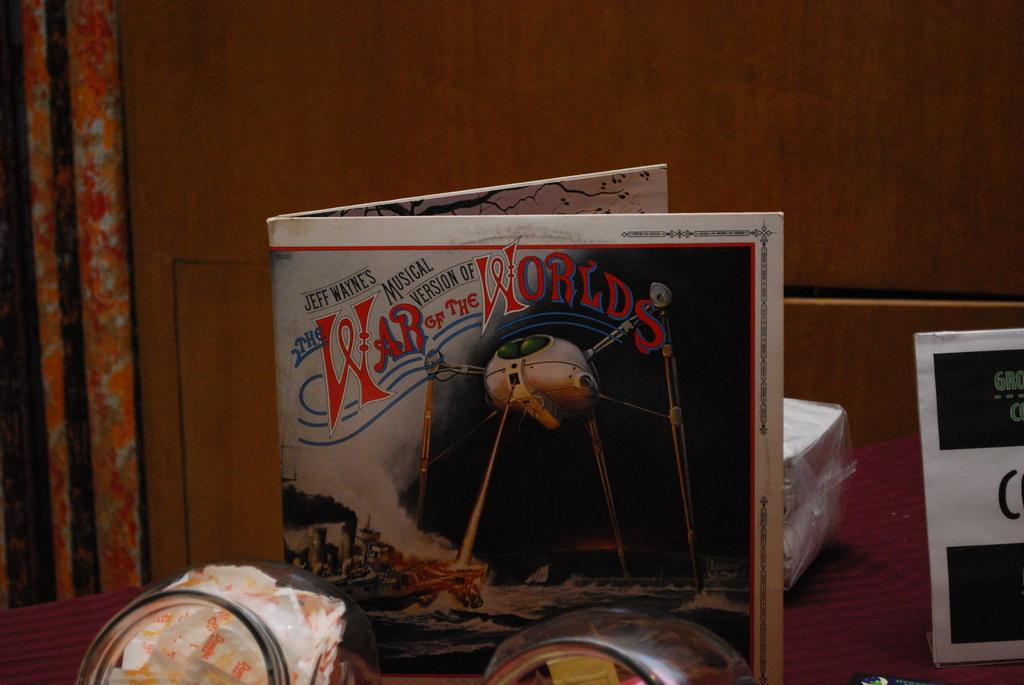<image>
Write a terse but informative summary of the picture. A War of the worlds paper standing upright on a table. 